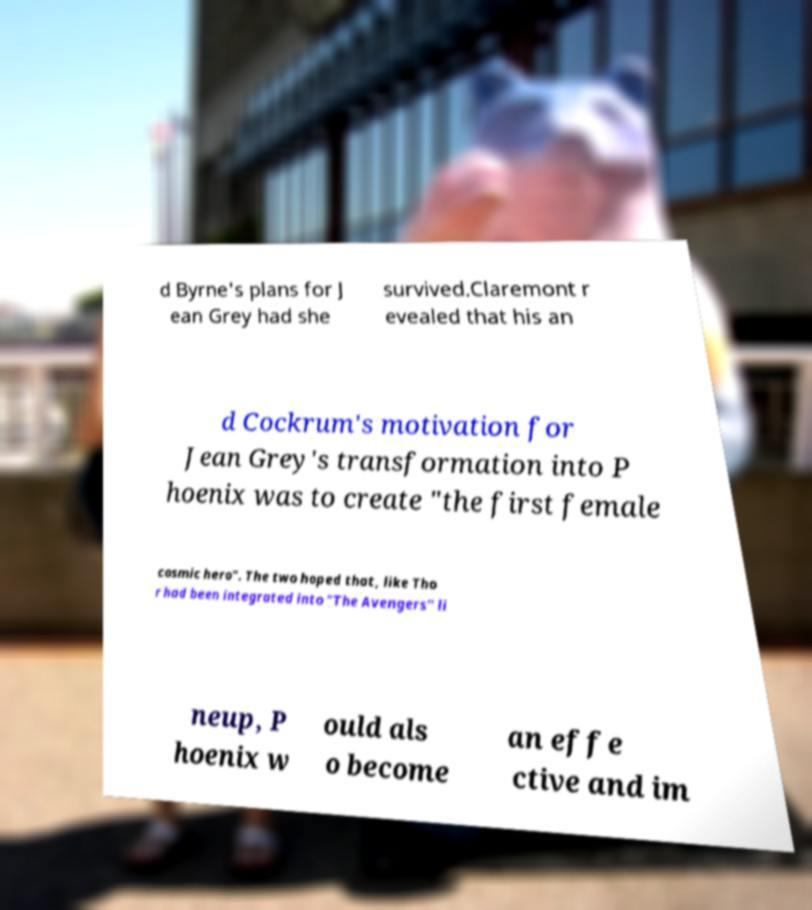What messages or text are displayed in this image? I need them in a readable, typed format. d Byrne's plans for J ean Grey had she survived.Claremont r evealed that his an d Cockrum's motivation for Jean Grey's transformation into P hoenix was to create "the first female cosmic hero". The two hoped that, like Tho r had been integrated into "The Avengers" li neup, P hoenix w ould als o become an effe ctive and im 